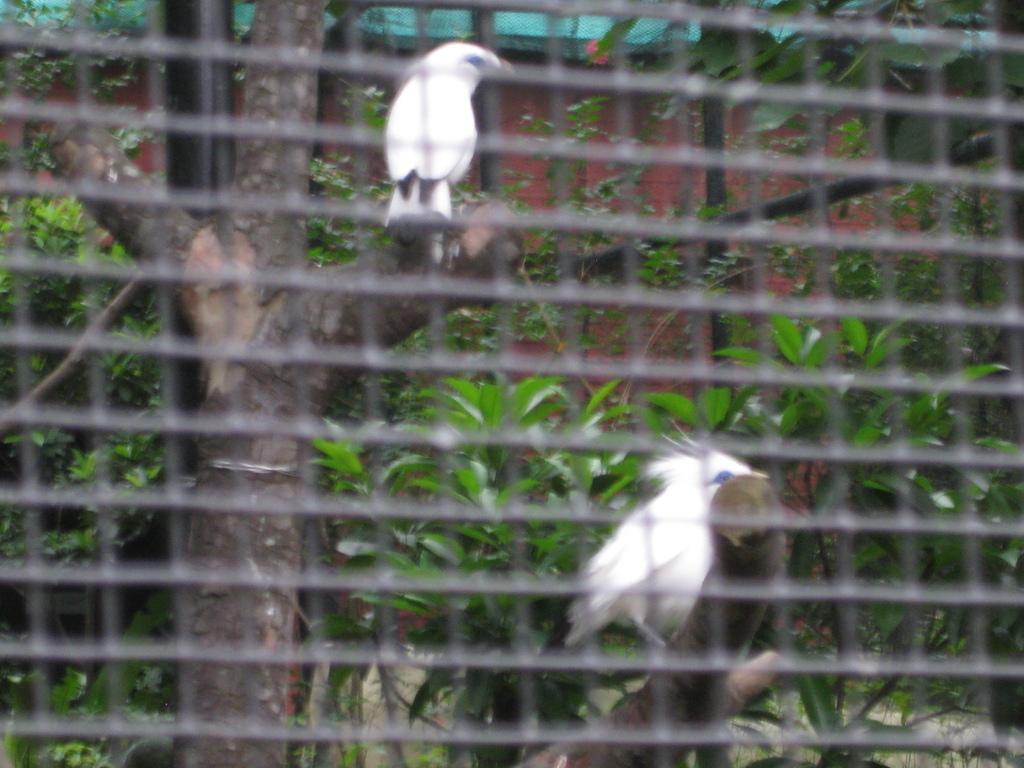Please provide a concise description of this image. In this image, we can see a mesh, birds on the tree and there are plants and there is a wall. 